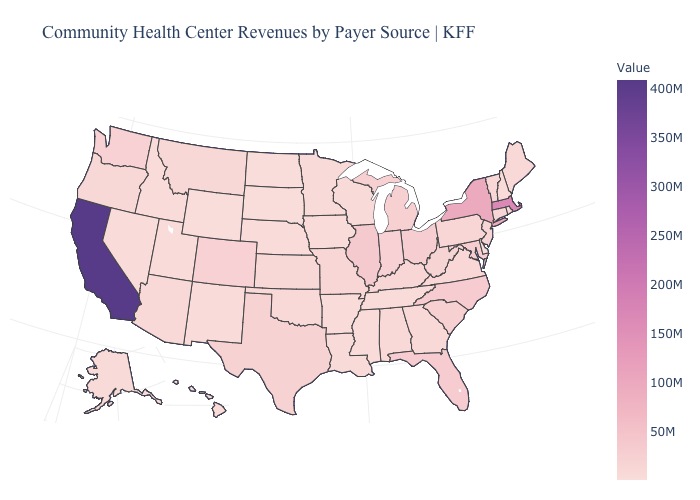Which states hav the highest value in the West?
Write a very short answer. California. Does California have the highest value in the West?
Be succinct. Yes. Among the states that border Kentucky , which have the highest value?
Answer briefly. Illinois. Which states hav the highest value in the Northeast?
Keep it brief. Massachusetts. 